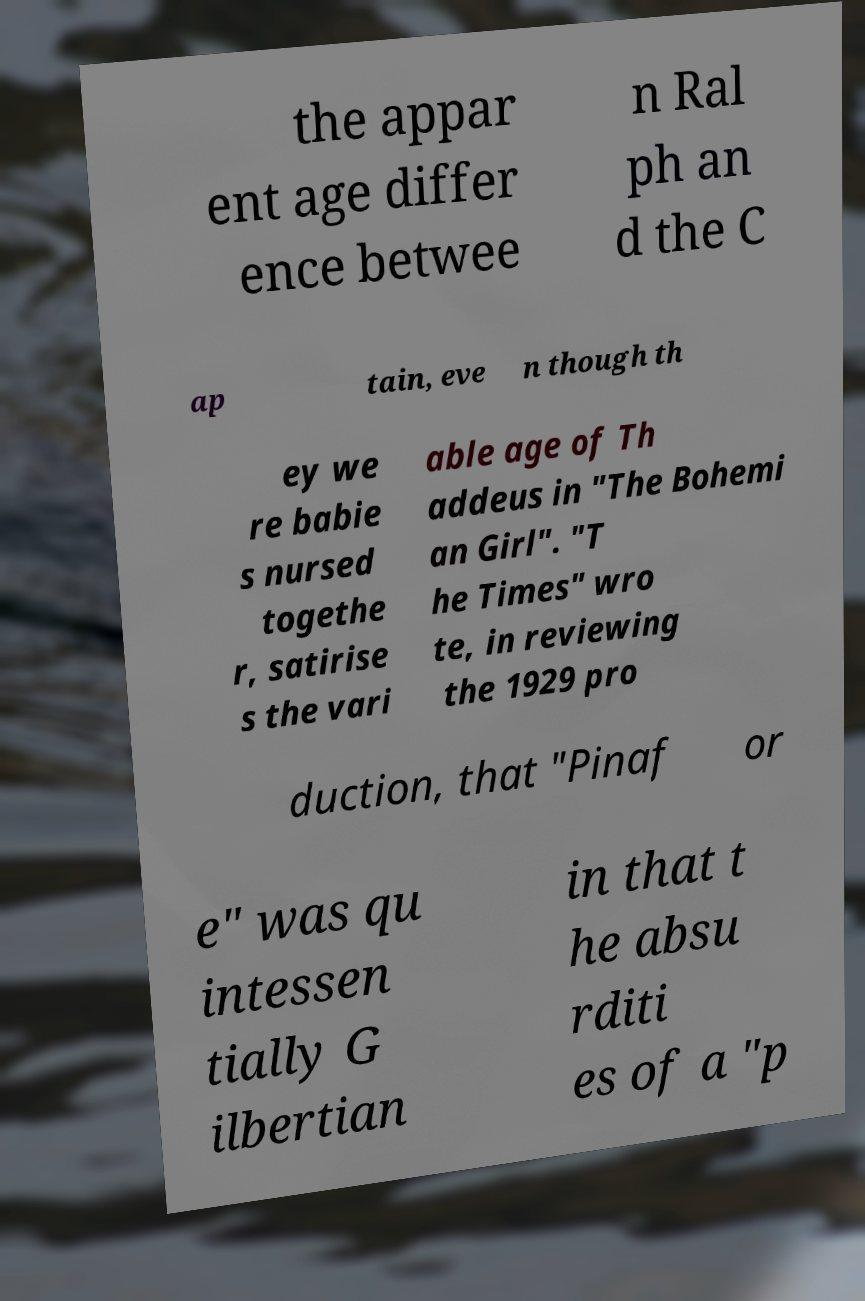Could you assist in decoding the text presented in this image and type it out clearly? the appar ent age differ ence betwee n Ral ph an d the C ap tain, eve n though th ey we re babie s nursed togethe r, satirise s the vari able age of Th addeus in "The Bohemi an Girl". "T he Times" wro te, in reviewing the 1929 pro duction, that "Pinaf or e" was qu intessen tially G ilbertian in that t he absu rditi es of a "p 